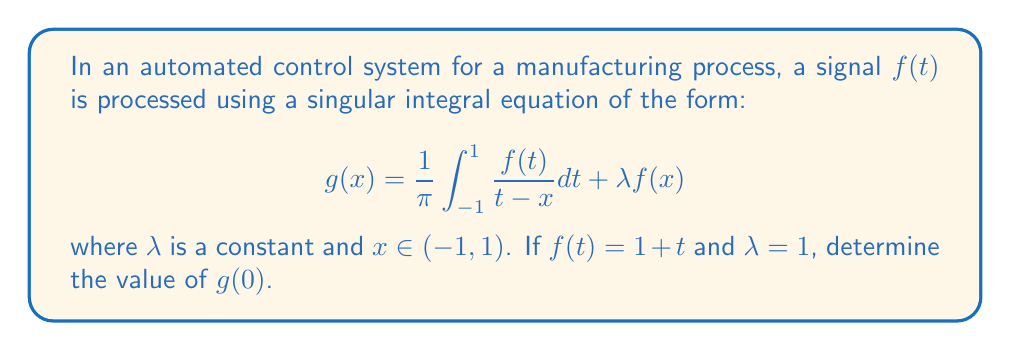Can you answer this question? To solve this problem, we'll follow these steps:

1) First, we substitute the given values into the singular integral equation:

   $$g(0) = \frac{1}{\pi} \int_{-1}^{1} \frac{1+t}{t-0} dt + 1(1+0)$$

2) Simplify:

   $$g(0) = \frac{1}{\pi} \int_{-1}^{1} \frac{1+t}{t} dt + 1$$

3) Split the integral:

   $$g(0) = \frac{1}{\pi} \left(\int_{-1}^{1} \frac{1}{t} dt + \int_{-1}^{1} dt\right) + 1$$

4) Evaluate the integrals:

   $$g(0) = \frac{1}{\pi} \left(\left[\ln|t|\right]_{-1}^{1} + \left[t\right]_{-1}^{1}\right) + 1$$

5) Compute the definite integrals:

   $$g(0) = \frac{1}{\pi} \left((\ln|1| - \ln|-1|) + (1 - (-1))\right) + 1$$

6) Simplify:

   $$g(0) = \frac{1}{\pi} (0 + 2) + 1$$

7) Calculate the final result:

   $$g(0) = \frac{2}{\pi} + 1$$
Answer: $\frac{2}{\pi} + 1$ 